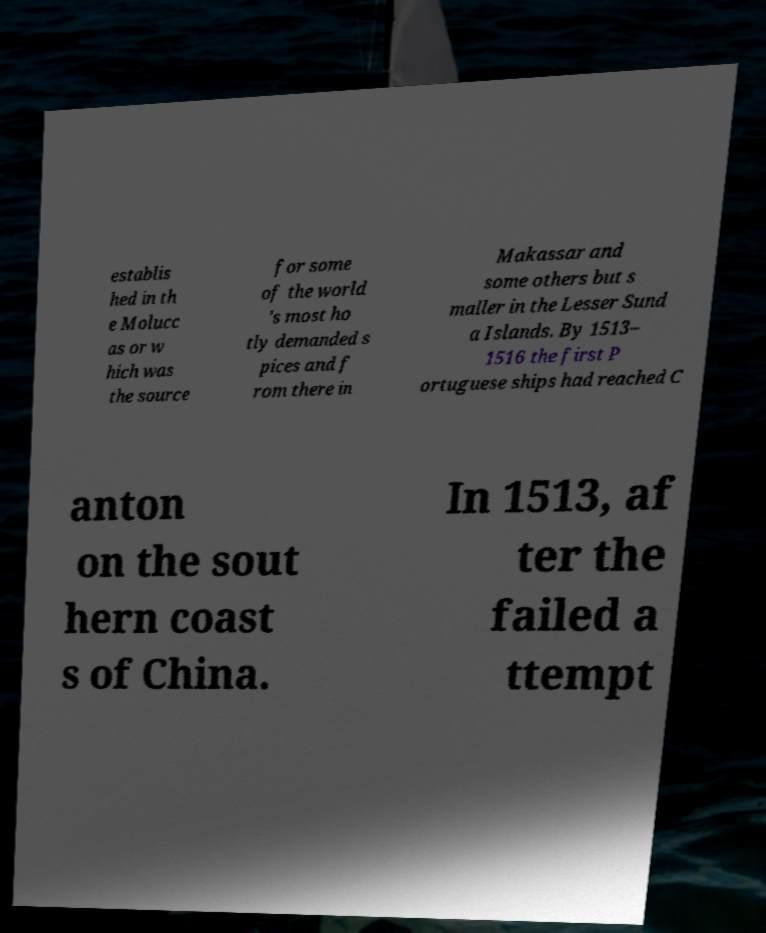There's text embedded in this image that I need extracted. Can you transcribe it verbatim? establis hed in th e Molucc as or w hich was the source for some of the world 's most ho tly demanded s pices and f rom there in Makassar and some others but s maller in the Lesser Sund a Islands. By 1513– 1516 the first P ortuguese ships had reached C anton on the sout hern coast s of China. In 1513, af ter the failed a ttempt 